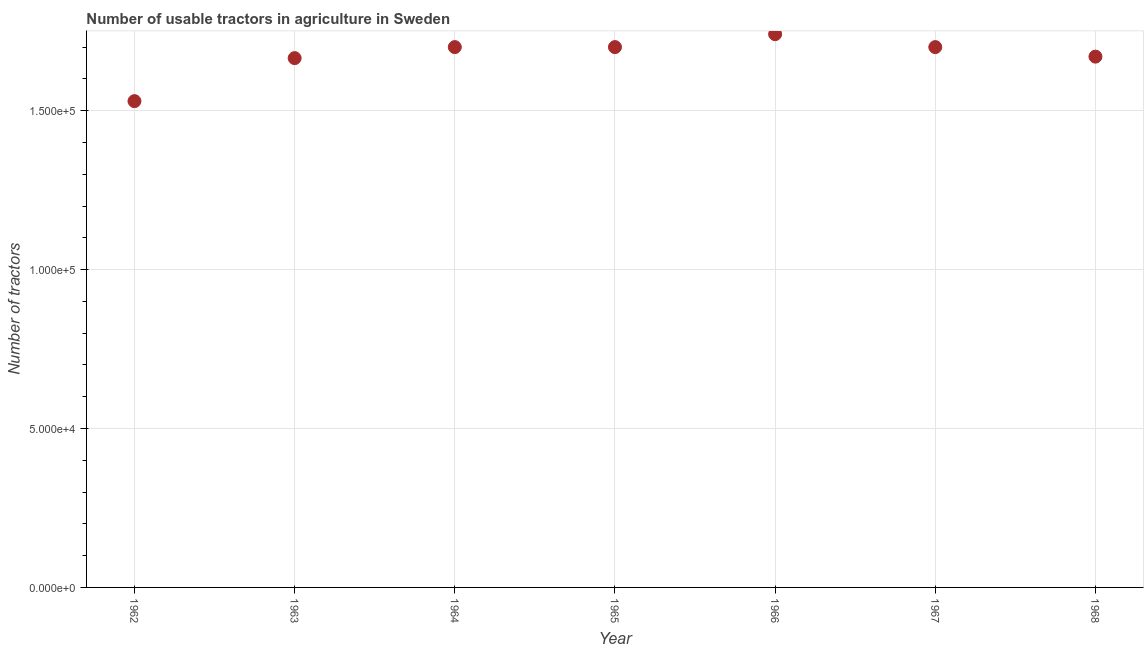What is the number of tractors in 1964?
Ensure brevity in your answer.  1.70e+05. Across all years, what is the maximum number of tractors?
Your response must be concise. 1.74e+05. Across all years, what is the minimum number of tractors?
Keep it short and to the point. 1.53e+05. In which year was the number of tractors maximum?
Provide a short and direct response. 1966. In which year was the number of tractors minimum?
Offer a very short reply. 1962. What is the sum of the number of tractors?
Keep it short and to the point. 1.17e+06. What is the difference between the number of tractors in 1963 and 1964?
Your answer should be very brief. -3468. What is the average number of tractors per year?
Provide a short and direct response. 1.67e+05. What is the median number of tractors?
Give a very brief answer. 1.70e+05. Do a majority of the years between 1963 and 1966 (inclusive) have number of tractors greater than 100000 ?
Offer a terse response. Yes. Is the number of tractors in 1962 less than that in 1966?
Offer a very short reply. Yes. Is the difference between the number of tractors in 1964 and 1967 greater than the difference between any two years?
Give a very brief answer. No. What is the difference between the highest and the second highest number of tractors?
Your response must be concise. 4067. Is the sum of the number of tractors in 1964 and 1966 greater than the maximum number of tractors across all years?
Offer a very short reply. Yes. What is the difference between the highest and the lowest number of tractors?
Ensure brevity in your answer.  2.11e+04. In how many years, is the number of tractors greater than the average number of tractors taken over all years?
Provide a short and direct response. 4. What is the difference between two consecutive major ticks on the Y-axis?
Ensure brevity in your answer.  5.00e+04. Are the values on the major ticks of Y-axis written in scientific E-notation?
Your response must be concise. Yes. Does the graph contain grids?
Provide a succinct answer. Yes. What is the title of the graph?
Keep it short and to the point. Number of usable tractors in agriculture in Sweden. What is the label or title of the X-axis?
Offer a very short reply. Year. What is the label or title of the Y-axis?
Make the answer very short. Number of tractors. What is the Number of tractors in 1962?
Ensure brevity in your answer.  1.53e+05. What is the Number of tractors in 1963?
Provide a succinct answer. 1.67e+05. What is the Number of tractors in 1964?
Offer a very short reply. 1.70e+05. What is the Number of tractors in 1966?
Provide a succinct answer. 1.74e+05. What is the Number of tractors in 1968?
Offer a terse response. 1.67e+05. What is the difference between the Number of tractors in 1962 and 1963?
Offer a very short reply. -1.35e+04. What is the difference between the Number of tractors in 1962 and 1964?
Ensure brevity in your answer.  -1.70e+04. What is the difference between the Number of tractors in 1962 and 1965?
Keep it short and to the point. -1.70e+04. What is the difference between the Number of tractors in 1962 and 1966?
Give a very brief answer. -2.11e+04. What is the difference between the Number of tractors in 1962 and 1967?
Provide a succinct answer. -1.70e+04. What is the difference between the Number of tractors in 1962 and 1968?
Provide a succinct answer. -1.40e+04. What is the difference between the Number of tractors in 1963 and 1964?
Give a very brief answer. -3468. What is the difference between the Number of tractors in 1963 and 1965?
Offer a very short reply. -3468. What is the difference between the Number of tractors in 1963 and 1966?
Provide a succinct answer. -7535. What is the difference between the Number of tractors in 1963 and 1967?
Your answer should be very brief. -3468. What is the difference between the Number of tractors in 1963 and 1968?
Your response must be concise. -468. What is the difference between the Number of tractors in 1964 and 1965?
Offer a terse response. 0. What is the difference between the Number of tractors in 1964 and 1966?
Provide a short and direct response. -4067. What is the difference between the Number of tractors in 1964 and 1968?
Keep it short and to the point. 3000. What is the difference between the Number of tractors in 1965 and 1966?
Give a very brief answer. -4067. What is the difference between the Number of tractors in 1965 and 1967?
Ensure brevity in your answer.  0. What is the difference between the Number of tractors in 1965 and 1968?
Give a very brief answer. 3000. What is the difference between the Number of tractors in 1966 and 1967?
Ensure brevity in your answer.  4067. What is the difference between the Number of tractors in 1966 and 1968?
Your response must be concise. 7067. What is the difference between the Number of tractors in 1967 and 1968?
Offer a terse response. 3000. What is the ratio of the Number of tractors in 1962 to that in 1963?
Offer a very short reply. 0.92. What is the ratio of the Number of tractors in 1962 to that in 1964?
Keep it short and to the point. 0.9. What is the ratio of the Number of tractors in 1962 to that in 1966?
Your response must be concise. 0.88. What is the ratio of the Number of tractors in 1962 to that in 1968?
Your answer should be very brief. 0.92. What is the ratio of the Number of tractors in 1963 to that in 1964?
Make the answer very short. 0.98. What is the ratio of the Number of tractors in 1963 to that in 1965?
Your response must be concise. 0.98. What is the ratio of the Number of tractors in 1963 to that in 1968?
Your response must be concise. 1. What is the ratio of the Number of tractors in 1964 to that in 1965?
Ensure brevity in your answer.  1. What is the ratio of the Number of tractors in 1964 to that in 1966?
Make the answer very short. 0.98. What is the ratio of the Number of tractors in 1966 to that in 1968?
Provide a short and direct response. 1.04. What is the ratio of the Number of tractors in 1967 to that in 1968?
Offer a very short reply. 1.02. 